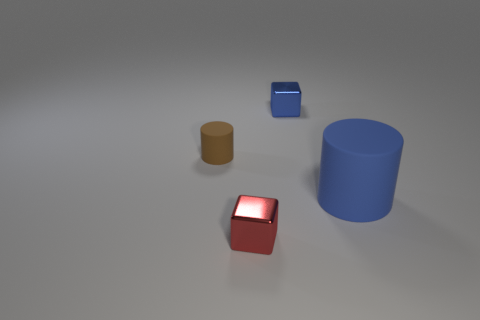Add 2 big blue things. How many objects exist? 6 Subtract all big blue cylinders. Subtract all small blue objects. How many objects are left? 2 Add 4 rubber cylinders. How many rubber cylinders are left? 6 Add 3 large brown shiny cylinders. How many large brown shiny cylinders exist? 3 Subtract 0 yellow cylinders. How many objects are left? 4 